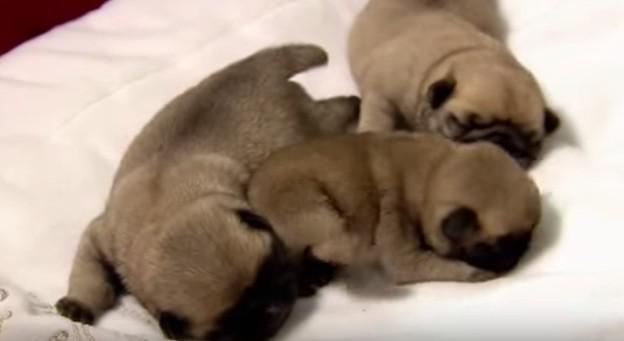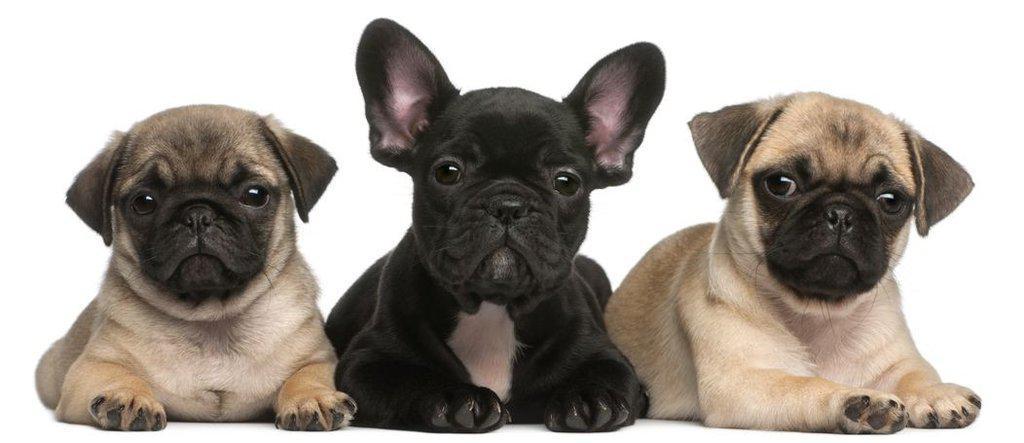The first image is the image on the left, the second image is the image on the right. For the images displayed, is the sentence "There are exactly three dogs in the right image." factually correct? Answer yes or no. Yes. The first image is the image on the left, the second image is the image on the right. Analyze the images presented: Is the assertion "Each image contains multiple pugs, and one image shows a trio of pugs with a black one in the middle." valid? Answer yes or no. Yes. 